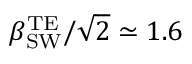<formula> <loc_0><loc_0><loc_500><loc_500>\beta _ { S W } ^ { T E } / \sqrt { 2 } \simeq 1 . 6</formula> 